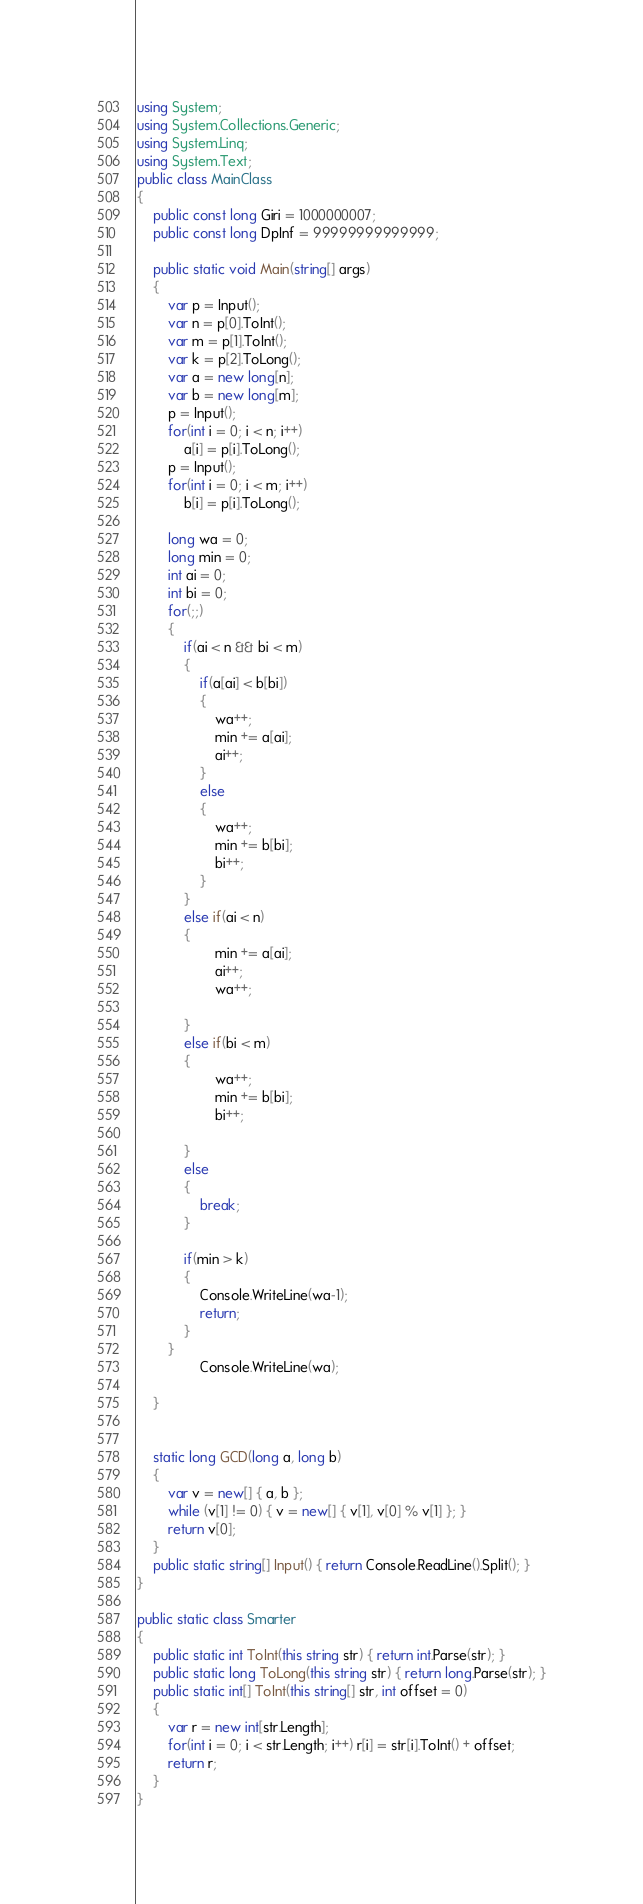Convert code to text. <code><loc_0><loc_0><loc_500><loc_500><_C#_>using System;
using System.Collections.Generic;
using System.Linq;
using System.Text;
public class MainClass
{
	public const long Giri = 1000000007;
	public const long DpInf = 99999999999999;
	
	public static void Main(string[] args)
	{
		var p = Input();
		var n = p[0].ToInt();
		var m = p[1].ToInt();
		var k = p[2].ToLong();
		var a = new long[n];
		var b = new long[m];
		p = Input();
		for(int i = 0; i < n; i++)
			a[i] = p[i].ToLong();
		p = Input();
		for(int i = 0; i < m; i++)
			b[i] = p[i].ToLong();
		
		long wa = 0;
		long min = 0;
		int ai = 0;
		int bi = 0;
		for(;;)
		{
			if(ai < n && bi < m)
			{
				if(a[ai] < b[bi])
				{
					wa++;
					min += a[ai];
					ai++;
				}
				else
				{
					wa++;
					min += b[bi];
					bi++;
				}
			}
			else if(ai < n)
			{
					min += a[ai];
					ai++;
					wa++;
			
			}
			else if(bi < m)
			{
					wa++;
					min += b[bi];
					bi++;
			
			}
			else
			{
				break;
			}
			
			if(min > k)
			{
				Console.WriteLine(wa-1);
				return;
			}
		}
				Console.WriteLine(wa);
		
	}

	
	static long GCD(long a, long b)
	{
		var v = new[] { a, b };
		while (v[1] != 0) { v = new[] { v[1], v[0] % v[1] }; }
		return v[0];
	}
	public static string[] Input() { return Console.ReadLine().Split(); }
}

public static class Smarter
{
	public static int ToInt(this string str) { return int.Parse(str); }
	public static long ToLong(this string str) { return long.Parse(str); }
	public static int[] ToInt(this string[] str, int offset = 0)
	{
		var r = new int[str.Length];
		for(int i = 0; i < str.Length; i++) r[i] = str[i].ToInt() + offset;
		return r;
	}
}</code> 